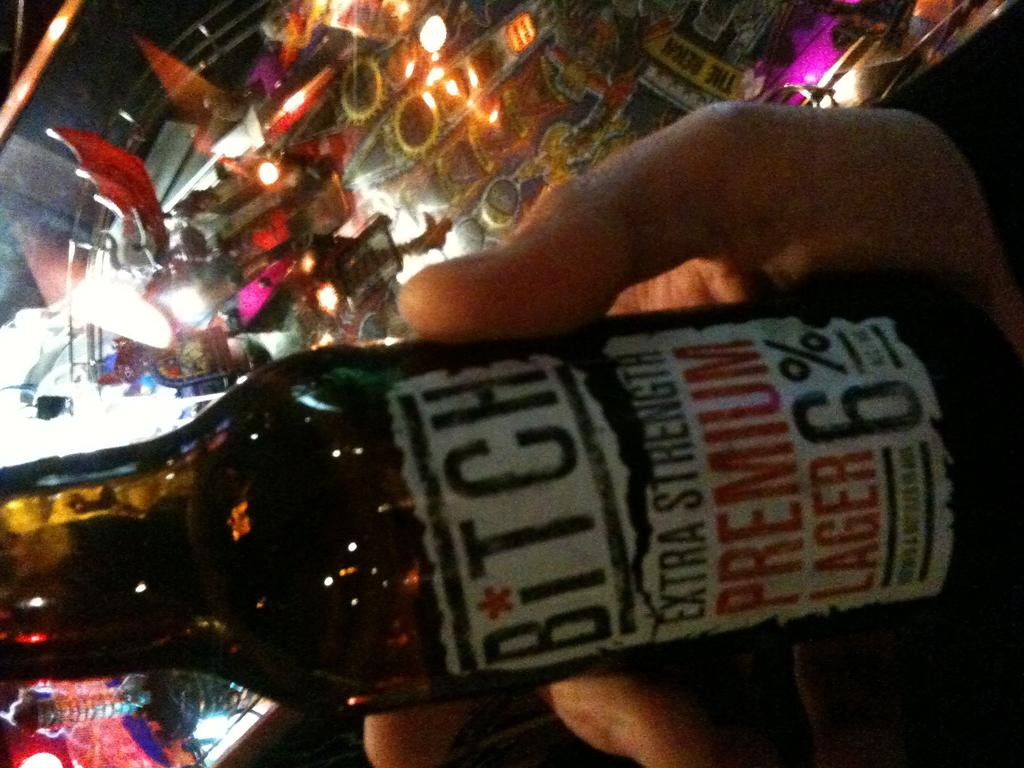<image>
Present a compact description of the photo's key features. Hand holding a bottle of Bitch Extra Strength Premium Lager 6% alcohol content 